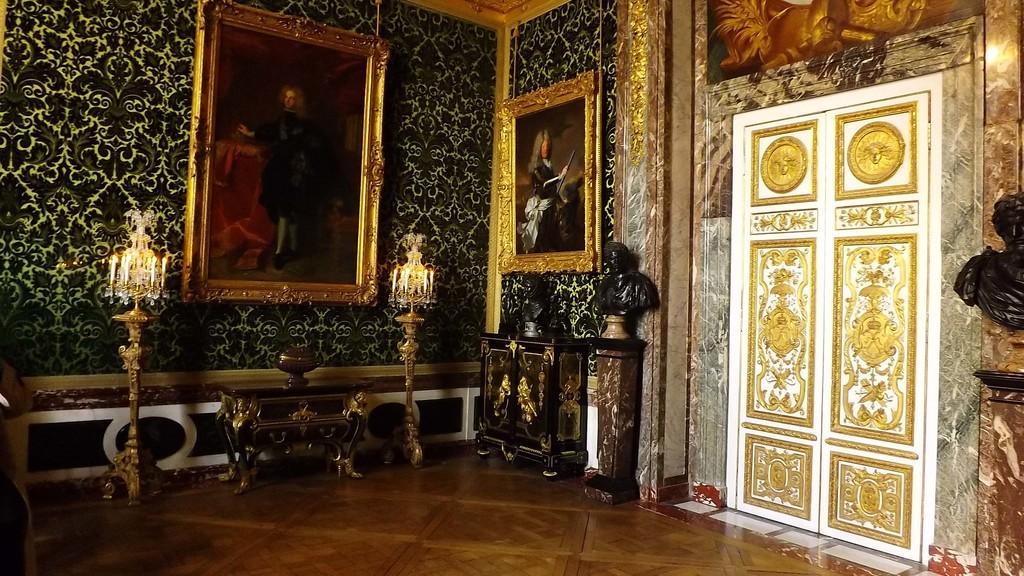Can you describe this image briefly? This is clicked inside a room, there is door with golden design on the right side followed by idols on table, on right side there are lamps on either side of picture on the wall and the floor is of wood. 